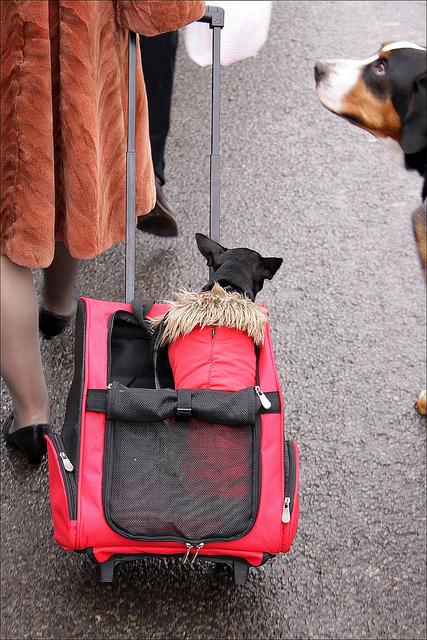What is the big dog doing?
Answer briefly. Standing. How many human legs do you see?
Keep it brief. 3. Is there a fur coat in this picture?
Write a very short answer. Yes. 